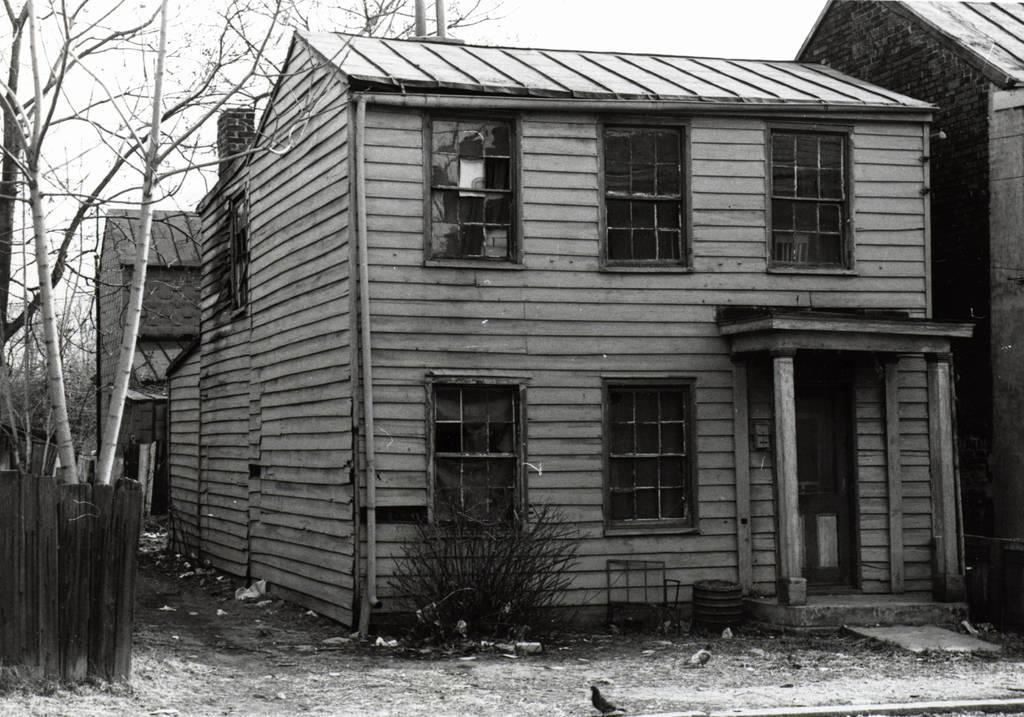Please provide a concise description of this image. In this image I can see houses, windows, plants, fence and the sky. This image is taken may be outside the house. 